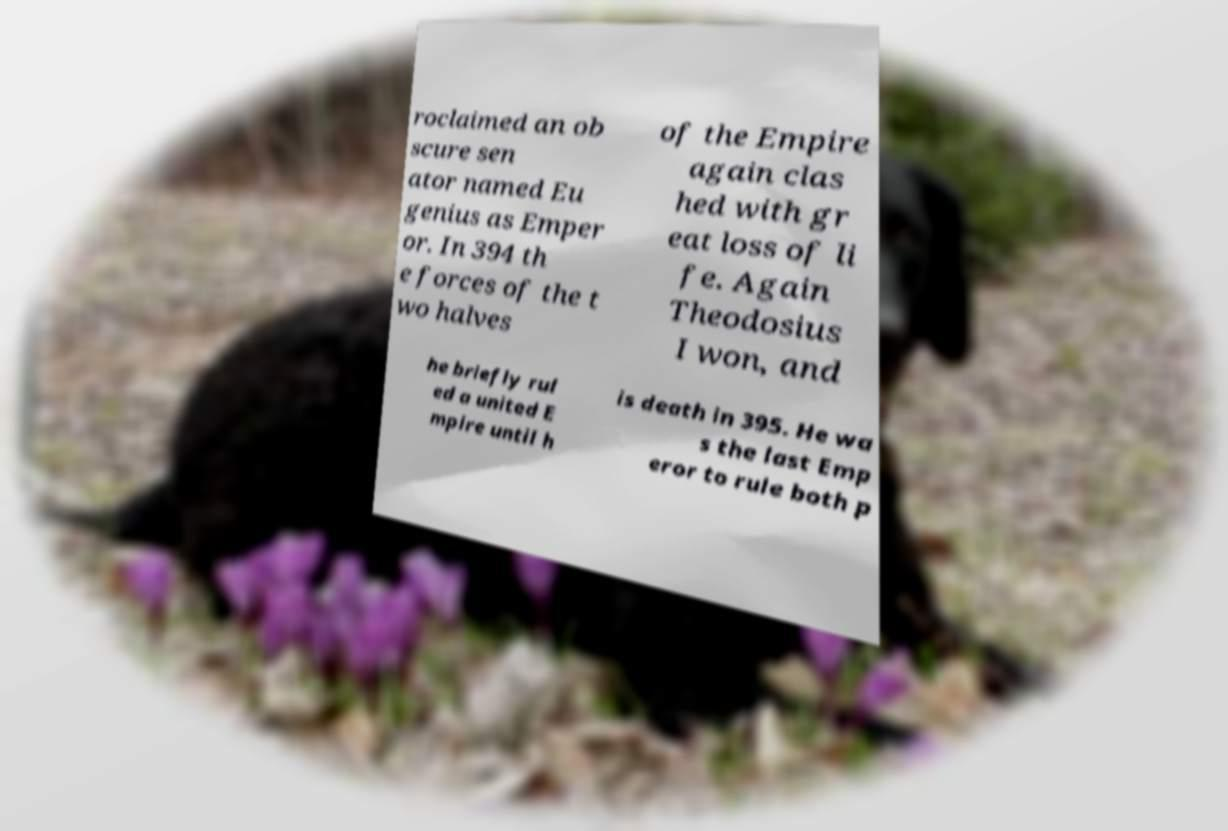There's text embedded in this image that I need extracted. Can you transcribe it verbatim? roclaimed an ob scure sen ator named Eu genius as Emper or. In 394 th e forces of the t wo halves of the Empire again clas hed with gr eat loss of li fe. Again Theodosius I won, and he briefly rul ed a united E mpire until h is death in 395. He wa s the last Emp eror to rule both p 